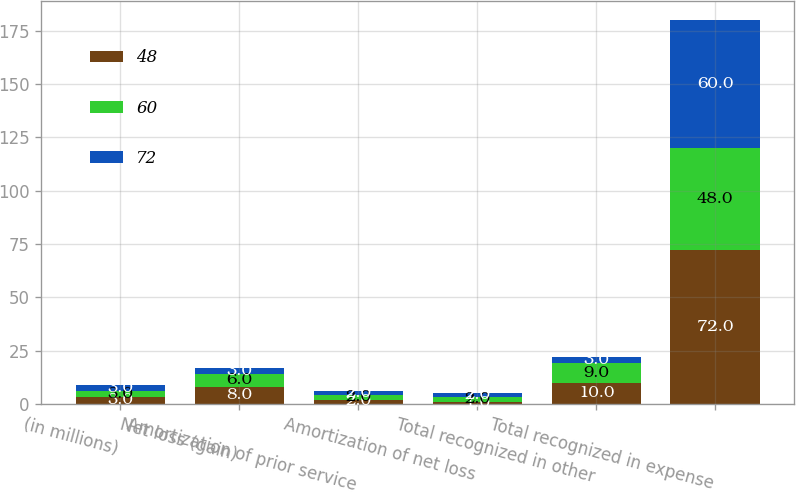<chart> <loc_0><loc_0><loc_500><loc_500><stacked_bar_chart><ecel><fcel>(in millions)<fcel>Net loss (gain)<fcel>Amortization of prior service<fcel>Amortization of net loss<fcel>Total recognized in other<fcel>Total recognized in expense<nl><fcel>48<fcel>3<fcel>8<fcel>2<fcel>1<fcel>10<fcel>72<nl><fcel>60<fcel>3<fcel>6<fcel>2<fcel>2<fcel>9<fcel>48<nl><fcel>72<fcel>3<fcel>3<fcel>2<fcel>2<fcel>3<fcel>60<nl></chart> 